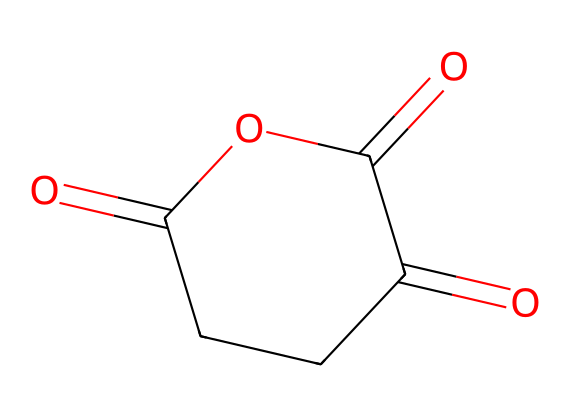What is the molecular formula of succinic anhydride? The molecular formula can be derived from the SMILES representation by counting the atoms present. The structure includes 4 carbon atoms, 4 hydrogen atoms, and 3 oxygen atoms, leading to a formula of C4H4O3.
Answer: C4H4O3 How many carbon atoms are in succinic anhydride? By interpreting the SMILES representation, we identify there are 4 'C' symbols, indicating 4 carbon atoms in the structure.
Answer: 4 What type of functional groups are present in succinic anhydride? Looking at the structure, we observe that succinic anhydride features carbonyl (C=O) and ether (C-O) groups. The presence of these groups characterizes the compound as an acid anhydride.
Answer: carbonyl and ether Which type of acid does succinic anhydride derive from? Recognizing the structure, succinic anhydride is derived from succinic acid, which is a dicarboxylic acid. This is inferred from the presence of the carbonyl groups that correspond to carboxylic acids.
Answer: succinic acid What is the number of oxygen atoms in succinic anhydride? In the SMILES representation, we see 'O' symbols present. Counting them reveals that there are 3 oxygen atoms in the chemical structure.
Answer: 3 What makes succinic anhydride an anhydride? An acid anhydride is formed by the removal of water from two carboxylic acid molecules. In succinic anhydride's structure, the cyclic arrangement and presence of carbonyl groups confirm its formation as an anhydride.
Answer: cyclic arrangement Does succinic anhydride have a ring structure? Analyzing the SMILES, we observe 'C1' and 'C' connections that indicate the formation of a cyclic structure in succinic anhydride. Thus, we can confirm it has a ring structure.
Answer: yes 